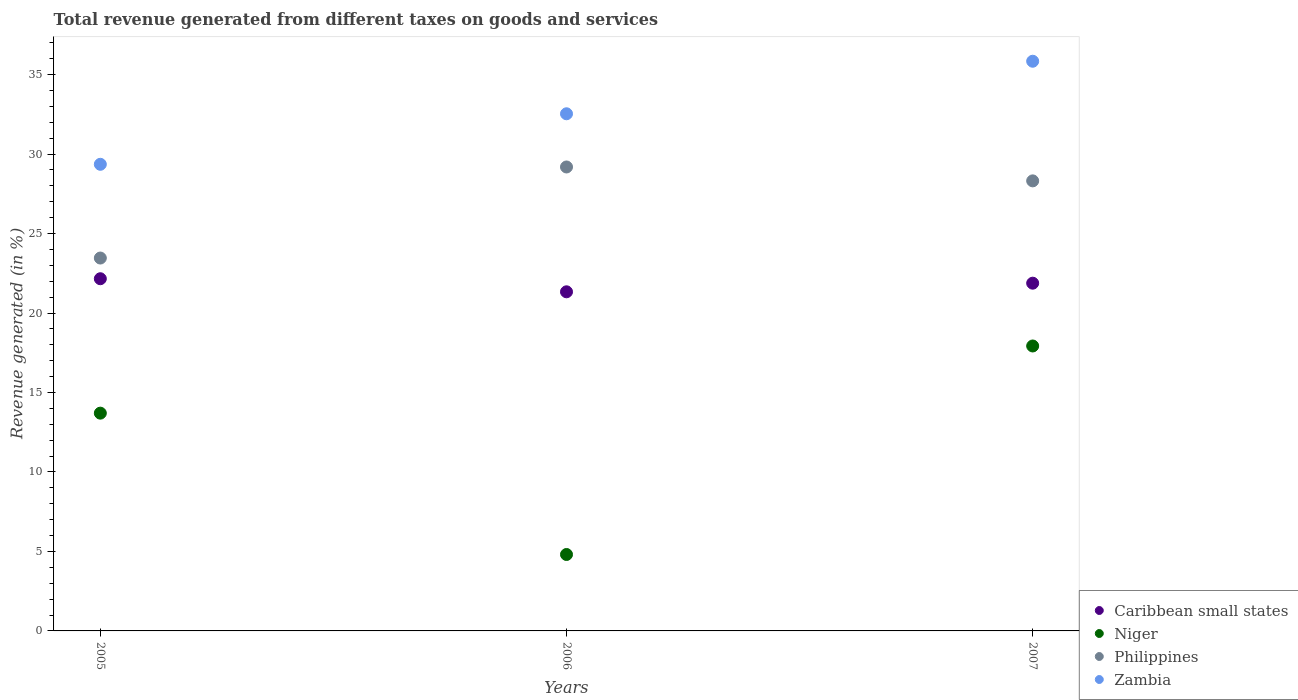How many different coloured dotlines are there?
Offer a terse response. 4. What is the total revenue generated in Zambia in 2007?
Keep it short and to the point. 35.84. Across all years, what is the maximum total revenue generated in Philippines?
Provide a short and direct response. 29.19. Across all years, what is the minimum total revenue generated in Niger?
Make the answer very short. 4.81. In which year was the total revenue generated in Zambia minimum?
Offer a terse response. 2005. What is the total total revenue generated in Caribbean small states in the graph?
Make the answer very short. 65.37. What is the difference between the total revenue generated in Philippines in 2005 and that in 2006?
Your response must be concise. -5.73. What is the difference between the total revenue generated in Niger in 2006 and the total revenue generated in Philippines in 2005?
Offer a very short reply. -18.65. What is the average total revenue generated in Zambia per year?
Offer a terse response. 32.58. In the year 2006, what is the difference between the total revenue generated in Zambia and total revenue generated in Caribbean small states?
Provide a succinct answer. 11.2. What is the ratio of the total revenue generated in Zambia in 2005 to that in 2007?
Offer a terse response. 0.82. Is the difference between the total revenue generated in Zambia in 2005 and 2006 greater than the difference between the total revenue generated in Caribbean small states in 2005 and 2006?
Provide a succinct answer. No. What is the difference between the highest and the second highest total revenue generated in Philippines?
Your answer should be compact. 0.87. What is the difference between the highest and the lowest total revenue generated in Caribbean small states?
Make the answer very short. 0.82. In how many years, is the total revenue generated in Caribbean small states greater than the average total revenue generated in Caribbean small states taken over all years?
Ensure brevity in your answer.  2. Is the sum of the total revenue generated in Zambia in 2005 and 2006 greater than the maximum total revenue generated in Philippines across all years?
Keep it short and to the point. Yes. Is it the case that in every year, the sum of the total revenue generated in Niger and total revenue generated in Zambia  is greater than the total revenue generated in Caribbean small states?
Make the answer very short. Yes. How many dotlines are there?
Offer a very short reply. 4. What is the difference between two consecutive major ticks on the Y-axis?
Ensure brevity in your answer.  5. Does the graph contain any zero values?
Ensure brevity in your answer.  No. Does the graph contain grids?
Your answer should be compact. No. How many legend labels are there?
Make the answer very short. 4. How are the legend labels stacked?
Provide a short and direct response. Vertical. What is the title of the graph?
Your answer should be compact. Total revenue generated from different taxes on goods and services. Does "Uganda" appear as one of the legend labels in the graph?
Ensure brevity in your answer.  No. What is the label or title of the Y-axis?
Provide a succinct answer. Revenue generated (in %). What is the Revenue generated (in %) in Caribbean small states in 2005?
Keep it short and to the point. 22.16. What is the Revenue generated (in %) of Niger in 2005?
Offer a very short reply. 13.7. What is the Revenue generated (in %) of Philippines in 2005?
Ensure brevity in your answer.  23.46. What is the Revenue generated (in %) in Zambia in 2005?
Keep it short and to the point. 29.36. What is the Revenue generated (in %) in Caribbean small states in 2006?
Ensure brevity in your answer.  21.34. What is the Revenue generated (in %) of Niger in 2006?
Offer a terse response. 4.81. What is the Revenue generated (in %) in Philippines in 2006?
Ensure brevity in your answer.  29.19. What is the Revenue generated (in %) of Zambia in 2006?
Offer a very short reply. 32.54. What is the Revenue generated (in %) of Caribbean small states in 2007?
Ensure brevity in your answer.  21.88. What is the Revenue generated (in %) in Niger in 2007?
Ensure brevity in your answer.  17.93. What is the Revenue generated (in %) of Philippines in 2007?
Ensure brevity in your answer.  28.31. What is the Revenue generated (in %) of Zambia in 2007?
Make the answer very short. 35.84. Across all years, what is the maximum Revenue generated (in %) of Caribbean small states?
Provide a succinct answer. 22.16. Across all years, what is the maximum Revenue generated (in %) in Niger?
Offer a very short reply. 17.93. Across all years, what is the maximum Revenue generated (in %) of Philippines?
Provide a succinct answer. 29.19. Across all years, what is the maximum Revenue generated (in %) of Zambia?
Make the answer very short. 35.84. Across all years, what is the minimum Revenue generated (in %) of Caribbean small states?
Offer a terse response. 21.34. Across all years, what is the minimum Revenue generated (in %) of Niger?
Your response must be concise. 4.81. Across all years, what is the minimum Revenue generated (in %) of Philippines?
Ensure brevity in your answer.  23.46. Across all years, what is the minimum Revenue generated (in %) in Zambia?
Keep it short and to the point. 29.36. What is the total Revenue generated (in %) of Caribbean small states in the graph?
Offer a terse response. 65.37. What is the total Revenue generated (in %) in Niger in the graph?
Your response must be concise. 36.44. What is the total Revenue generated (in %) of Philippines in the graph?
Your answer should be very brief. 80.96. What is the total Revenue generated (in %) of Zambia in the graph?
Keep it short and to the point. 97.73. What is the difference between the Revenue generated (in %) of Caribbean small states in 2005 and that in 2006?
Your answer should be very brief. 0.82. What is the difference between the Revenue generated (in %) in Niger in 2005 and that in 2006?
Offer a very short reply. 8.89. What is the difference between the Revenue generated (in %) in Philippines in 2005 and that in 2006?
Keep it short and to the point. -5.73. What is the difference between the Revenue generated (in %) of Zambia in 2005 and that in 2006?
Your response must be concise. -3.18. What is the difference between the Revenue generated (in %) in Caribbean small states in 2005 and that in 2007?
Ensure brevity in your answer.  0.28. What is the difference between the Revenue generated (in %) of Niger in 2005 and that in 2007?
Your response must be concise. -4.23. What is the difference between the Revenue generated (in %) of Philippines in 2005 and that in 2007?
Ensure brevity in your answer.  -4.86. What is the difference between the Revenue generated (in %) of Zambia in 2005 and that in 2007?
Offer a terse response. -6.48. What is the difference between the Revenue generated (in %) in Caribbean small states in 2006 and that in 2007?
Keep it short and to the point. -0.54. What is the difference between the Revenue generated (in %) of Niger in 2006 and that in 2007?
Offer a very short reply. -13.12. What is the difference between the Revenue generated (in %) of Philippines in 2006 and that in 2007?
Your answer should be compact. 0.87. What is the difference between the Revenue generated (in %) of Zambia in 2006 and that in 2007?
Your response must be concise. -3.31. What is the difference between the Revenue generated (in %) of Caribbean small states in 2005 and the Revenue generated (in %) of Niger in 2006?
Your response must be concise. 17.35. What is the difference between the Revenue generated (in %) in Caribbean small states in 2005 and the Revenue generated (in %) in Philippines in 2006?
Your answer should be very brief. -7.03. What is the difference between the Revenue generated (in %) of Caribbean small states in 2005 and the Revenue generated (in %) of Zambia in 2006?
Your answer should be compact. -10.38. What is the difference between the Revenue generated (in %) in Niger in 2005 and the Revenue generated (in %) in Philippines in 2006?
Ensure brevity in your answer.  -15.49. What is the difference between the Revenue generated (in %) in Niger in 2005 and the Revenue generated (in %) in Zambia in 2006?
Offer a terse response. -18.83. What is the difference between the Revenue generated (in %) of Philippines in 2005 and the Revenue generated (in %) of Zambia in 2006?
Offer a terse response. -9.08. What is the difference between the Revenue generated (in %) of Caribbean small states in 2005 and the Revenue generated (in %) of Niger in 2007?
Make the answer very short. 4.23. What is the difference between the Revenue generated (in %) of Caribbean small states in 2005 and the Revenue generated (in %) of Philippines in 2007?
Provide a short and direct response. -6.16. What is the difference between the Revenue generated (in %) in Caribbean small states in 2005 and the Revenue generated (in %) in Zambia in 2007?
Offer a very short reply. -13.68. What is the difference between the Revenue generated (in %) of Niger in 2005 and the Revenue generated (in %) of Philippines in 2007?
Provide a short and direct response. -14.61. What is the difference between the Revenue generated (in %) in Niger in 2005 and the Revenue generated (in %) in Zambia in 2007?
Your response must be concise. -22.14. What is the difference between the Revenue generated (in %) of Philippines in 2005 and the Revenue generated (in %) of Zambia in 2007?
Your answer should be compact. -12.38. What is the difference between the Revenue generated (in %) of Caribbean small states in 2006 and the Revenue generated (in %) of Niger in 2007?
Give a very brief answer. 3.41. What is the difference between the Revenue generated (in %) of Caribbean small states in 2006 and the Revenue generated (in %) of Philippines in 2007?
Offer a terse response. -6.98. What is the difference between the Revenue generated (in %) of Caribbean small states in 2006 and the Revenue generated (in %) of Zambia in 2007?
Your answer should be very brief. -14.51. What is the difference between the Revenue generated (in %) in Niger in 2006 and the Revenue generated (in %) in Philippines in 2007?
Keep it short and to the point. -23.51. What is the difference between the Revenue generated (in %) in Niger in 2006 and the Revenue generated (in %) in Zambia in 2007?
Offer a very short reply. -31.03. What is the difference between the Revenue generated (in %) in Philippines in 2006 and the Revenue generated (in %) in Zambia in 2007?
Your response must be concise. -6.65. What is the average Revenue generated (in %) in Caribbean small states per year?
Make the answer very short. 21.79. What is the average Revenue generated (in %) in Niger per year?
Ensure brevity in your answer.  12.15. What is the average Revenue generated (in %) in Philippines per year?
Your answer should be compact. 26.99. What is the average Revenue generated (in %) in Zambia per year?
Your answer should be very brief. 32.58. In the year 2005, what is the difference between the Revenue generated (in %) of Caribbean small states and Revenue generated (in %) of Niger?
Offer a terse response. 8.46. In the year 2005, what is the difference between the Revenue generated (in %) in Caribbean small states and Revenue generated (in %) in Philippines?
Your answer should be compact. -1.3. In the year 2005, what is the difference between the Revenue generated (in %) of Caribbean small states and Revenue generated (in %) of Zambia?
Make the answer very short. -7.2. In the year 2005, what is the difference between the Revenue generated (in %) in Niger and Revenue generated (in %) in Philippines?
Make the answer very short. -9.76. In the year 2005, what is the difference between the Revenue generated (in %) in Niger and Revenue generated (in %) in Zambia?
Offer a terse response. -15.66. In the year 2005, what is the difference between the Revenue generated (in %) in Philippines and Revenue generated (in %) in Zambia?
Your answer should be compact. -5.9. In the year 2006, what is the difference between the Revenue generated (in %) of Caribbean small states and Revenue generated (in %) of Niger?
Provide a succinct answer. 16.53. In the year 2006, what is the difference between the Revenue generated (in %) of Caribbean small states and Revenue generated (in %) of Philippines?
Your answer should be compact. -7.85. In the year 2006, what is the difference between the Revenue generated (in %) of Caribbean small states and Revenue generated (in %) of Zambia?
Provide a short and direct response. -11.2. In the year 2006, what is the difference between the Revenue generated (in %) of Niger and Revenue generated (in %) of Philippines?
Ensure brevity in your answer.  -24.38. In the year 2006, what is the difference between the Revenue generated (in %) of Niger and Revenue generated (in %) of Zambia?
Offer a very short reply. -27.73. In the year 2006, what is the difference between the Revenue generated (in %) of Philippines and Revenue generated (in %) of Zambia?
Offer a very short reply. -3.35. In the year 2007, what is the difference between the Revenue generated (in %) in Caribbean small states and Revenue generated (in %) in Niger?
Offer a very short reply. 3.95. In the year 2007, what is the difference between the Revenue generated (in %) of Caribbean small states and Revenue generated (in %) of Philippines?
Ensure brevity in your answer.  -6.44. In the year 2007, what is the difference between the Revenue generated (in %) of Caribbean small states and Revenue generated (in %) of Zambia?
Give a very brief answer. -13.96. In the year 2007, what is the difference between the Revenue generated (in %) of Niger and Revenue generated (in %) of Philippines?
Your answer should be compact. -10.39. In the year 2007, what is the difference between the Revenue generated (in %) in Niger and Revenue generated (in %) in Zambia?
Provide a short and direct response. -17.91. In the year 2007, what is the difference between the Revenue generated (in %) in Philippines and Revenue generated (in %) in Zambia?
Keep it short and to the point. -7.53. What is the ratio of the Revenue generated (in %) of Niger in 2005 to that in 2006?
Offer a terse response. 2.85. What is the ratio of the Revenue generated (in %) in Philippines in 2005 to that in 2006?
Provide a short and direct response. 0.8. What is the ratio of the Revenue generated (in %) in Zambia in 2005 to that in 2006?
Make the answer very short. 0.9. What is the ratio of the Revenue generated (in %) in Caribbean small states in 2005 to that in 2007?
Your answer should be very brief. 1.01. What is the ratio of the Revenue generated (in %) of Niger in 2005 to that in 2007?
Your response must be concise. 0.76. What is the ratio of the Revenue generated (in %) in Philippines in 2005 to that in 2007?
Keep it short and to the point. 0.83. What is the ratio of the Revenue generated (in %) in Zambia in 2005 to that in 2007?
Give a very brief answer. 0.82. What is the ratio of the Revenue generated (in %) of Caribbean small states in 2006 to that in 2007?
Your response must be concise. 0.98. What is the ratio of the Revenue generated (in %) of Niger in 2006 to that in 2007?
Your answer should be compact. 0.27. What is the ratio of the Revenue generated (in %) in Philippines in 2006 to that in 2007?
Offer a very short reply. 1.03. What is the ratio of the Revenue generated (in %) in Zambia in 2006 to that in 2007?
Provide a short and direct response. 0.91. What is the difference between the highest and the second highest Revenue generated (in %) in Caribbean small states?
Your answer should be compact. 0.28. What is the difference between the highest and the second highest Revenue generated (in %) of Niger?
Your answer should be compact. 4.23. What is the difference between the highest and the second highest Revenue generated (in %) in Philippines?
Your answer should be very brief. 0.87. What is the difference between the highest and the second highest Revenue generated (in %) in Zambia?
Offer a very short reply. 3.31. What is the difference between the highest and the lowest Revenue generated (in %) in Caribbean small states?
Give a very brief answer. 0.82. What is the difference between the highest and the lowest Revenue generated (in %) of Niger?
Give a very brief answer. 13.12. What is the difference between the highest and the lowest Revenue generated (in %) in Philippines?
Ensure brevity in your answer.  5.73. What is the difference between the highest and the lowest Revenue generated (in %) in Zambia?
Your answer should be very brief. 6.48. 